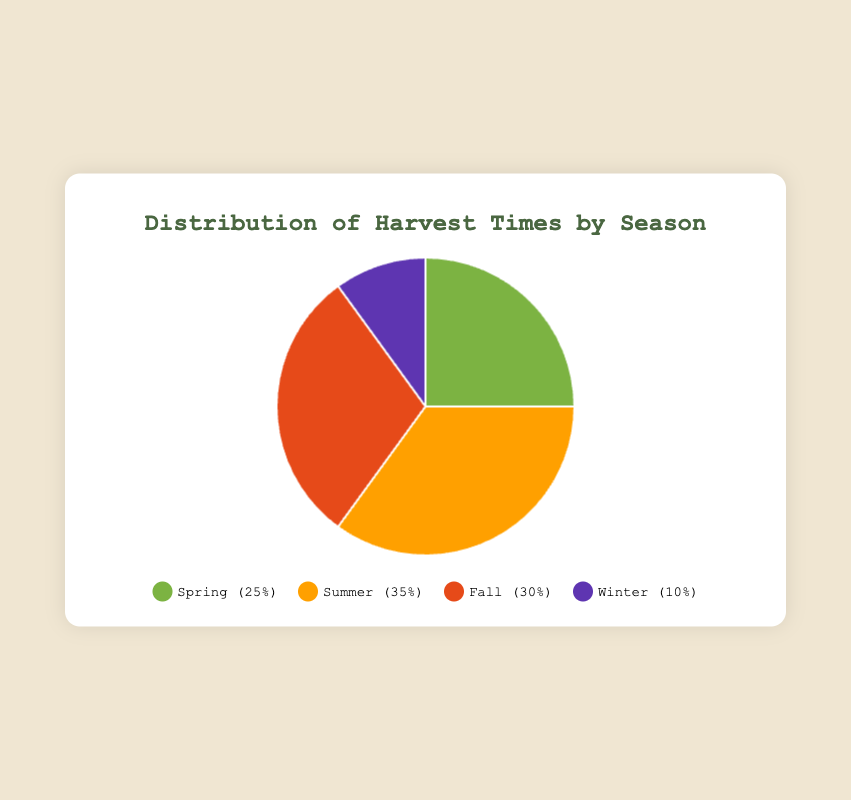What's the largest season in terms of harvest time percentage? By looking at the pie chart, the largest section represents the summer season, which accounts for 35% of the harvest time.
Answer: Summer Which season has the smallest harvest time percentage? The smallest section in the pie chart represents the winter season, which accounts for 10% of the harvest time.
Answer: Winter What is the combined harvest time percentage for Spring and Fall? The pie chart shows Spring has 25% and Fall has 30%. Adding these percentages together: 25% + 30% = 55%.
Answer: 55% How many products are harvested in Summer? Referring to the tooltip information, the pie chart labels reveal that Summer includes Tomatoes, Corn, and Cucumbers. Counting these, there are 3 products.
Answer: 3 How does the harvest time percentage of Fall compare to that of Spring? The pie chart shows that Fall has a 30% harvest time, while Spring has 25%. Therefore, Fall's harvest time is 5% greater than Spring's.
Answer: Fall is 5% greater What products are harvested in the season with the second-largest harvest time? The pie chart indicates that Fall is the season with the second-largest harvest time at 30%. The products associated with Fall are Pumpkins, Sweet Potatoes, and Apples.
Answer: Pumpkins, Sweet Potatoes, Apples What is the average harvest time percentage across all seasons? Summing all the percentages: 25% (Spring) + 35% (Summer) + 30% (Fall) + 10% (Winter) = 100%. Dividing by 4 (number of seasons), the average is 100% / 4 = 25%.
Answer: 25% Which season is represented by the color closest to red in the pie chart? The pie chart uses distinctive colors to represent different seasons. The color closest to red is used for Fall.
Answer: Fall What proportion of the total harvest time is accounted for by non-winter seasons? Winter accounts for 10% of the harvest time. Thus, non-winter seasons account for 100% - 10% = 90%.
Answer: 90% If Winter's harvest time increased by 10%, what would the new total be? If Winter's harvest time increased by 10%, it would go from 10% to 20%. Since the total must still be 100%, the new distribution would require adjustments in other seasons. However, the new Winter percentage alone is simply 20%.
Answer: 20% 